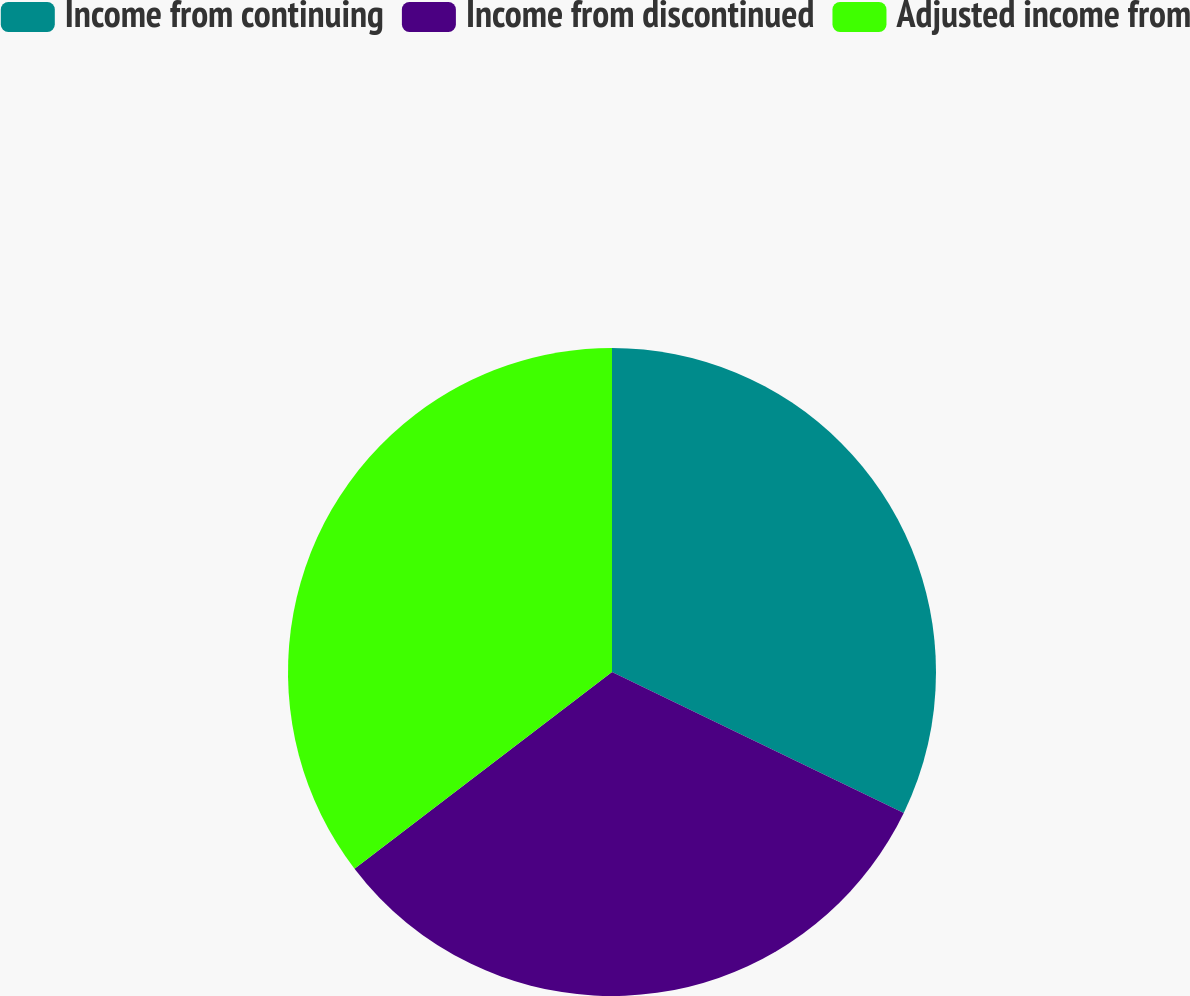Convert chart. <chart><loc_0><loc_0><loc_500><loc_500><pie_chart><fcel>Income from continuing<fcel>Income from discontinued<fcel>Adjusted income from<nl><fcel>32.16%<fcel>32.46%<fcel>35.38%<nl></chart> 